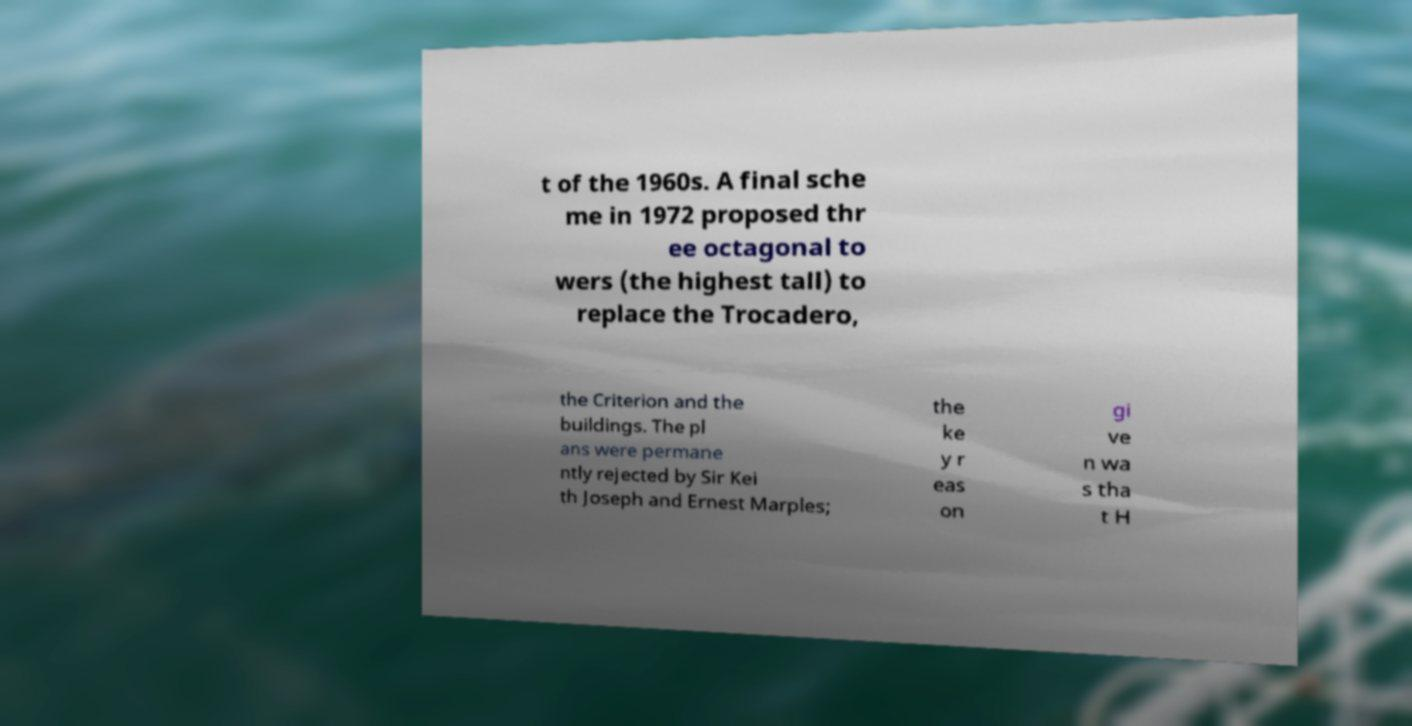For documentation purposes, I need the text within this image transcribed. Could you provide that? t of the 1960s. A final sche me in 1972 proposed thr ee octagonal to wers (the highest tall) to replace the Trocadero, the Criterion and the buildings. The pl ans were permane ntly rejected by Sir Kei th Joseph and Ernest Marples; the ke y r eas on gi ve n wa s tha t H 